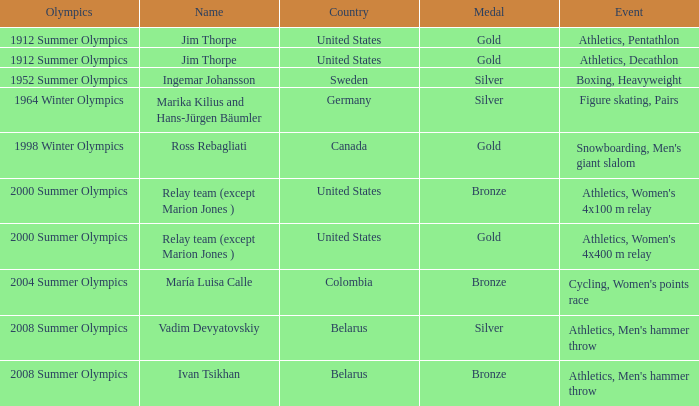What is the event in the 2000 summer olympics with a bronze medal? Athletics, Women's 4x100 m relay. 